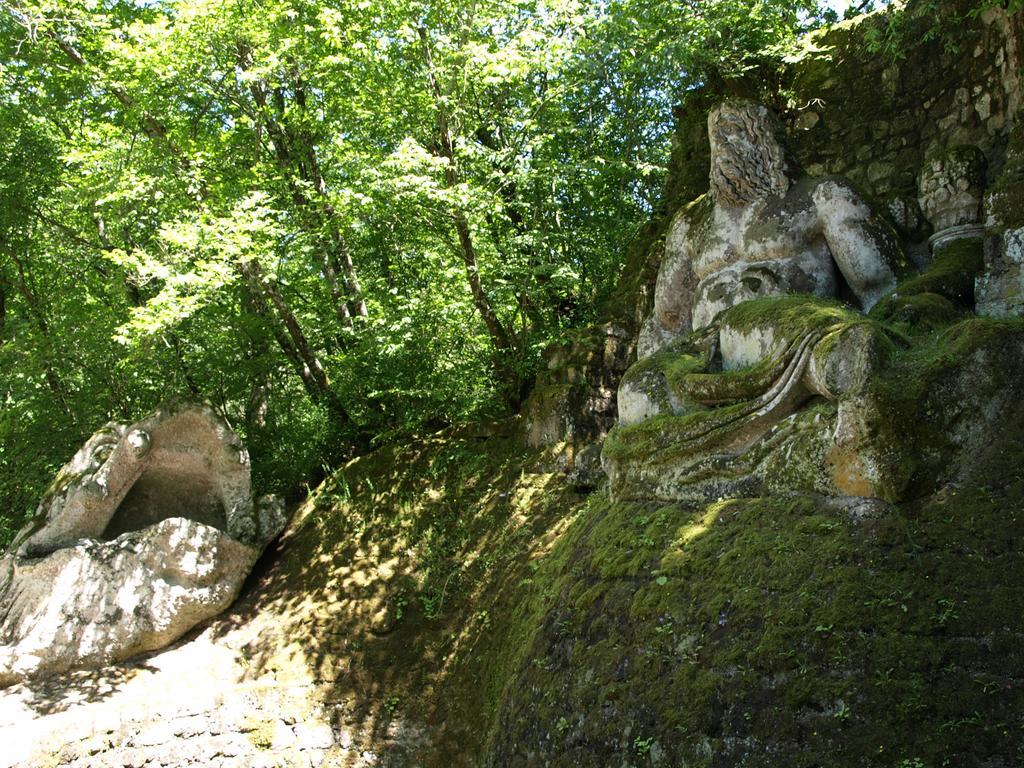How would you summarize this image in a sentence or two? In this picture, it seems like a sculpture and grassland in the foreground, there are trees and stones in the background. 